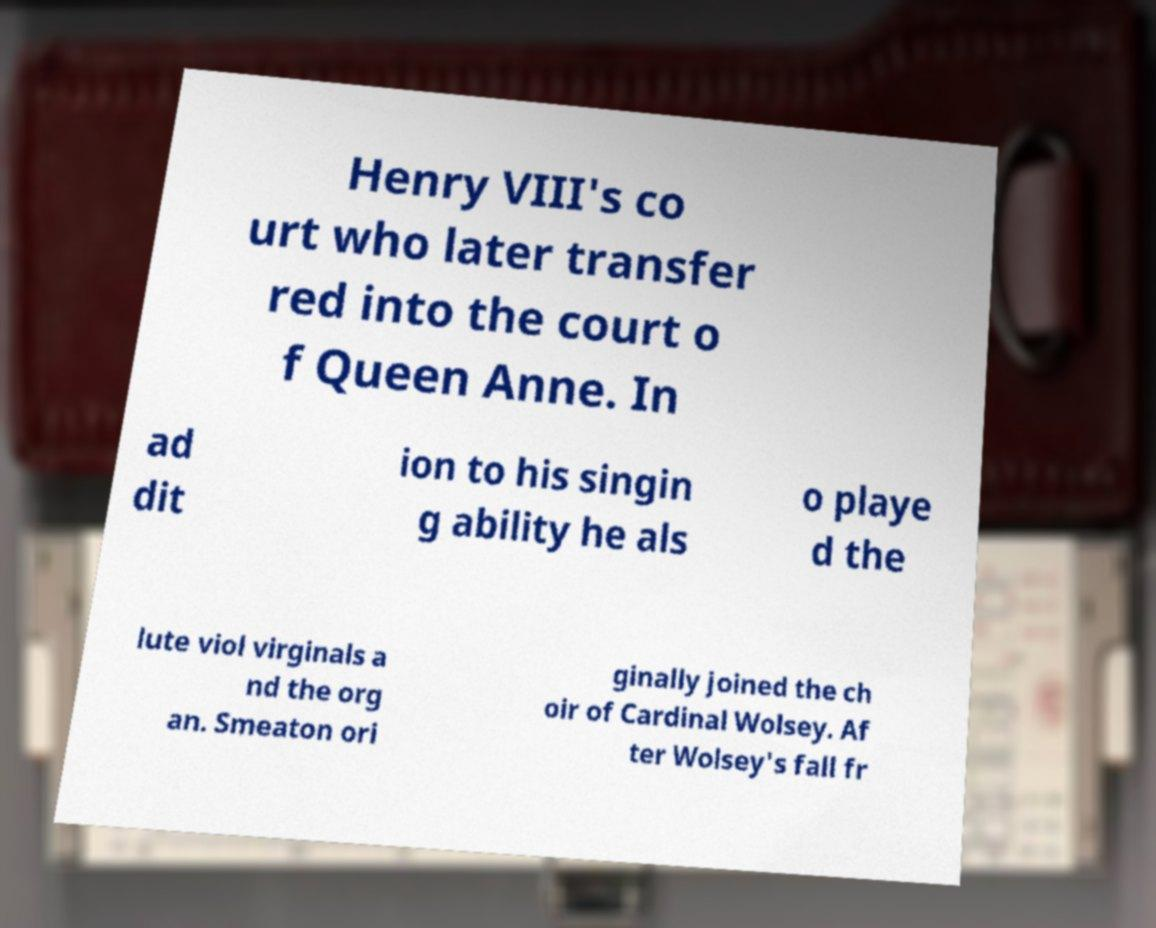I need the written content from this picture converted into text. Can you do that? Henry VIII's co urt who later transfer red into the court o f Queen Anne. In ad dit ion to his singin g ability he als o playe d the lute viol virginals a nd the org an. Smeaton ori ginally joined the ch oir of Cardinal Wolsey. Af ter Wolsey's fall fr 